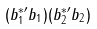<formula> <loc_0><loc_0><loc_500><loc_500>( b ^ { * \prime } _ { 1 } b _ { 1 } ) ( b ^ { * \prime } _ { 2 } b _ { 2 } )</formula> 